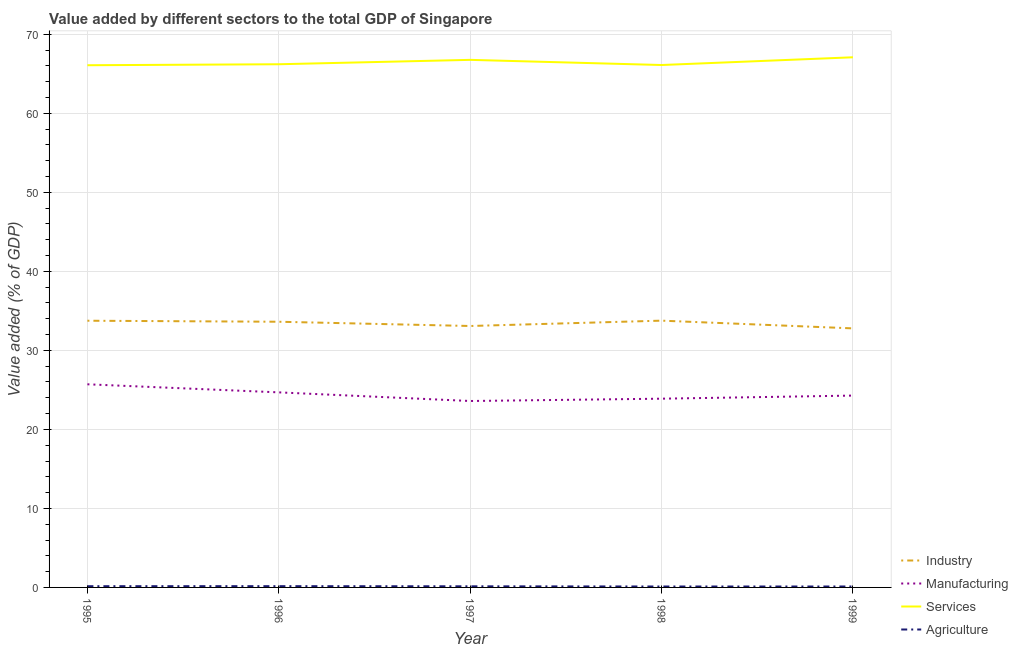Does the line corresponding to value added by services sector intersect with the line corresponding to value added by agricultural sector?
Give a very brief answer. No. Is the number of lines equal to the number of legend labels?
Make the answer very short. Yes. What is the value added by agricultural sector in 1996?
Make the answer very short. 0.16. Across all years, what is the maximum value added by industrial sector?
Offer a terse response. 33.76. Across all years, what is the minimum value added by industrial sector?
Your answer should be compact. 32.79. In which year was the value added by services sector maximum?
Your response must be concise. 1999. What is the total value added by manufacturing sector in the graph?
Your answer should be very brief. 122.16. What is the difference between the value added by agricultural sector in 1998 and that in 1999?
Make the answer very short. -0. What is the difference between the value added by industrial sector in 1999 and the value added by services sector in 1998?
Make the answer very short. -33.33. What is the average value added by industrial sector per year?
Your response must be concise. 33.4. In the year 1995, what is the difference between the value added by manufacturing sector and value added by agricultural sector?
Ensure brevity in your answer.  25.55. In how many years, is the value added by services sector greater than 12 %?
Offer a terse response. 5. What is the ratio of the value added by agricultural sector in 1995 to that in 1996?
Provide a succinct answer. 0.97. Is the difference between the value added by agricultural sector in 1997 and 1999 greater than the difference between the value added by industrial sector in 1997 and 1999?
Keep it short and to the point. No. What is the difference between the highest and the second highest value added by manufacturing sector?
Offer a very short reply. 1.02. What is the difference between the highest and the lowest value added by industrial sector?
Your answer should be compact. 0.98. In how many years, is the value added by services sector greater than the average value added by services sector taken over all years?
Your answer should be compact. 2. Is the value added by industrial sector strictly greater than the value added by agricultural sector over the years?
Your answer should be compact. Yes. Is the value added by services sector strictly less than the value added by manufacturing sector over the years?
Your response must be concise. No. How many lines are there?
Provide a succinct answer. 4. Where does the legend appear in the graph?
Make the answer very short. Bottom right. How many legend labels are there?
Your response must be concise. 4. What is the title of the graph?
Give a very brief answer. Value added by different sectors to the total GDP of Singapore. Does "Denmark" appear as one of the legend labels in the graph?
Your response must be concise. No. What is the label or title of the X-axis?
Offer a terse response. Year. What is the label or title of the Y-axis?
Provide a succinct answer. Value added (% of GDP). What is the Value added (% of GDP) of Industry in 1995?
Keep it short and to the point. 33.75. What is the Value added (% of GDP) in Manufacturing in 1995?
Offer a terse response. 25.71. What is the Value added (% of GDP) of Services in 1995?
Provide a succinct answer. 66.09. What is the Value added (% of GDP) in Agriculture in 1995?
Offer a very short reply. 0.16. What is the Value added (% of GDP) in Industry in 1996?
Make the answer very short. 33.63. What is the Value added (% of GDP) in Manufacturing in 1996?
Your answer should be compact. 24.69. What is the Value added (% of GDP) of Services in 1996?
Provide a short and direct response. 66.21. What is the Value added (% of GDP) in Agriculture in 1996?
Your response must be concise. 0.16. What is the Value added (% of GDP) in Industry in 1997?
Your answer should be very brief. 33.09. What is the Value added (% of GDP) of Manufacturing in 1997?
Give a very brief answer. 23.59. What is the Value added (% of GDP) in Services in 1997?
Your response must be concise. 66.77. What is the Value added (% of GDP) in Agriculture in 1997?
Your answer should be very brief. 0.14. What is the Value added (% of GDP) in Industry in 1998?
Give a very brief answer. 33.76. What is the Value added (% of GDP) of Manufacturing in 1998?
Make the answer very short. 23.89. What is the Value added (% of GDP) of Services in 1998?
Provide a short and direct response. 66.12. What is the Value added (% of GDP) in Agriculture in 1998?
Your answer should be compact. 0.12. What is the Value added (% of GDP) in Industry in 1999?
Provide a succinct answer. 32.79. What is the Value added (% of GDP) in Manufacturing in 1999?
Your response must be concise. 24.28. What is the Value added (% of GDP) in Services in 1999?
Offer a very short reply. 67.1. What is the Value added (% of GDP) of Agriculture in 1999?
Keep it short and to the point. 0.12. Across all years, what is the maximum Value added (% of GDP) in Industry?
Provide a succinct answer. 33.76. Across all years, what is the maximum Value added (% of GDP) of Manufacturing?
Keep it short and to the point. 25.71. Across all years, what is the maximum Value added (% of GDP) of Services?
Offer a very short reply. 67.1. Across all years, what is the maximum Value added (% of GDP) of Agriculture?
Offer a terse response. 0.16. Across all years, what is the minimum Value added (% of GDP) of Industry?
Offer a terse response. 32.79. Across all years, what is the minimum Value added (% of GDP) of Manufacturing?
Ensure brevity in your answer.  23.59. Across all years, what is the minimum Value added (% of GDP) in Services?
Provide a short and direct response. 66.09. Across all years, what is the minimum Value added (% of GDP) of Agriculture?
Your answer should be compact. 0.12. What is the total Value added (% of GDP) of Industry in the graph?
Your response must be concise. 167.02. What is the total Value added (% of GDP) of Manufacturing in the graph?
Your response must be concise. 122.16. What is the total Value added (% of GDP) in Services in the graph?
Ensure brevity in your answer.  332.29. What is the total Value added (% of GDP) in Agriculture in the graph?
Your answer should be very brief. 0.69. What is the difference between the Value added (% of GDP) of Industry in 1995 and that in 1996?
Offer a very short reply. 0.13. What is the difference between the Value added (% of GDP) of Manufacturing in 1995 and that in 1996?
Make the answer very short. 1.02. What is the difference between the Value added (% of GDP) in Services in 1995 and that in 1996?
Provide a short and direct response. -0.12. What is the difference between the Value added (% of GDP) in Agriculture in 1995 and that in 1996?
Provide a succinct answer. -0. What is the difference between the Value added (% of GDP) of Industry in 1995 and that in 1997?
Make the answer very short. 0.67. What is the difference between the Value added (% of GDP) in Manufacturing in 1995 and that in 1997?
Keep it short and to the point. 2.12. What is the difference between the Value added (% of GDP) in Services in 1995 and that in 1997?
Ensure brevity in your answer.  -0.68. What is the difference between the Value added (% of GDP) of Agriculture in 1995 and that in 1997?
Give a very brief answer. 0.01. What is the difference between the Value added (% of GDP) in Industry in 1995 and that in 1998?
Make the answer very short. -0.01. What is the difference between the Value added (% of GDP) of Manufacturing in 1995 and that in 1998?
Offer a very short reply. 1.82. What is the difference between the Value added (% of GDP) in Services in 1995 and that in 1998?
Offer a terse response. -0.03. What is the difference between the Value added (% of GDP) of Agriculture in 1995 and that in 1998?
Provide a short and direct response. 0.04. What is the difference between the Value added (% of GDP) in Manufacturing in 1995 and that in 1999?
Your response must be concise. 1.43. What is the difference between the Value added (% of GDP) of Services in 1995 and that in 1999?
Ensure brevity in your answer.  -1.01. What is the difference between the Value added (% of GDP) of Agriculture in 1995 and that in 1999?
Make the answer very short. 0.04. What is the difference between the Value added (% of GDP) in Industry in 1996 and that in 1997?
Your answer should be compact. 0.54. What is the difference between the Value added (% of GDP) in Manufacturing in 1996 and that in 1997?
Offer a very short reply. 1.09. What is the difference between the Value added (% of GDP) in Services in 1996 and that in 1997?
Make the answer very short. -0.56. What is the difference between the Value added (% of GDP) of Agriculture in 1996 and that in 1997?
Offer a very short reply. 0.02. What is the difference between the Value added (% of GDP) of Industry in 1996 and that in 1998?
Ensure brevity in your answer.  -0.14. What is the difference between the Value added (% of GDP) in Manufacturing in 1996 and that in 1998?
Your answer should be very brief. 0.8. What is the difference between the Value added (% of GDP) of Services in 1996 and that in 1998?
Ensure brevity in your answer.  0.1. What is the difference between the Value added (% of GDP) in Agriculture in 1996 and that in 1998?
Make the answer very short. 0.04. What is the difference between the Value added (% of GDP) of Industry in 1996 and that in 1999?
Make the answer very short. 0.84. What is the difference between the Value added (% of GDP) of Manufacturing in 1996 and that in 1999?
Your answer should be very brief. 0.41. What is the difference between the Value added (% of GDP) of Services in 1996 and that in 1999?
Offer a very short reply. -0.88. What is the difference between the Value added (% of GDP) in Agriculture in 1996 and that in 1999?
Make the answer very short. 0.04. What is the difference between the Value added (% of GDP) of Industry in 1997 and that in 1998?
Your answer should be compact. -0.68. What is the difference between the Value added (% of GDP) in Manufacturing in 1997 and that in 1998?
Provide a succinct answer. -0.29. What is the difference between the Value added (% of GDP) of Services in 1997 and that in 1998?
Provide a short and direct response. 0.65. What is the difference between the Value added (% of GDP) of Agriculture in 1997 and that in 1998?
Your answer should be compact. 0.02. What is the difference between the Value added (% of GDP) in Industry in 1997 and that in 1999?
Give a very brief answer. 0.3. What is the difference between the Value added (% of GDP) of Manufacturing in 1997 and that in 1999?
Ensure brevity in your answer.  -0.69. What is the difference between the Value added (% of GDP) of Services in 1997 and that in 1999?
Your response must be concise. -0.33. What is the difference between the Value added (% of GDP) in Agriculture in 1997 and that in 1999?
Provide a short and direct response. 0.02. What is the difference between the Value added (% of GDP) of Industry in 1998 and that in 1999?
Offer a terse response. 0.98. What is the difference between the Value added (% of GDP) in Manufacturing in 1998 and that in 1999?
Give a very brief answer. -0.39. What is the difference between the Value added (% of GDP) in Services in 1998 and that in 1999?
Provide a short and direct response. -0.98. What is the difference between the Value added (% of GDP) of Agriculture in 1998 and that in 1999?
Give a very brief answer. -0. What is the difference between the Value added (% of GDP) in Industry in 1995 and the Value added (% of GDP) in Manufacturing in 1996?
Ensure brevity in your answer.  9.07. What is the difference between the Value added (% of GDP) of Industry in 1995 and the Value added (% of GDP) of Services in 1996?
Give a very brief answer. -32.46. What is the difference between the Value added (% of GDP) in Industry in 1995 and the Value added (% of GDP) in Agriculture in 1996?
Offer a terse response. 33.59. What is the difference between the Value added (% of GDP) of Manufacturing in 1995 and the Value added (% of GDP) of Services in 1996?
Offer a terse response. -40.5. What is the difference between the Value added (% of GDP) of Manufacturing in 1995 and the Value added (% of GDP) of Agriculture in 1996?
Provide a short and direct response. 25.55. What is the difference between the Value added (% of GDP) in Services in 1995 and the Value added (% of GDP) in Agriculture in 1996?
Keep it short and to the point. 65.93. What is the difference between the Value added (% of GDP) in Industry in 1995 and the Value added (% of GDP) in Manufacturing in 1997?
Provide a succinct answer. 10.16. What is the difference between the Value added (% of GDP) of Industry in 1995 and the Value added (% of GDP) of Services in 1997?
Make the answer very short. -33.02. What is the difference between the Value added (% of GDP) in Industry in 1995 and the Value added (% of GDP) in Agriculture in 1997?
Provide a short and direct response. 33.61. What is the difference between the Value added (% of GDP) of Manufacturing in 1995 and the Value added (% of GDP) of Services in 1997?
Your answer should be very brief. -41.06. What is the difference between the Value added (% of GDP) of Manufacturing in 1995 and the Value added (% of GDP) of Agriculture in 1997?
Offer a very short reply. 25.57. What is the difference between the Value added (% of GDP) in Services in 1995 and the Value added (% of GDP) in Agriculture in 1997?
Your response must be concise. 65.95. What is the difference between the Value added (% of GDP) of Industry in 1995 and the Value added (% of GDP) of Manufacturing in 1998?
Ensure brevity in your answer.  9.87. What is the difference between the Value added (% of GDP) in Industry in 1995 and the Value added (% of GDP) in Services in 1998?
Keep it short and to the point. -32.36. What is the difference between the Value added (% of GDP) of Industry in 1995 and the Value added (% of GDP) of Agriculture in 1998?
Provide a succinct answer. 33.64. What is the difference between the Value added (% of GDP) of Manufacturing in 1995 and the Value added (% of GDP) of Services in 1998?
Provide a short and direct response. -40.41. What is the difference between the Value added (% of GDP) in Manufacturing in 1995 and the Value added (% of GDP) in Agriculture in 1998?
Offer a very short reply. 25.59. What is the difference between the Value added (% of GDP) in Services in 1995 and the Value added (% of GDP) in Agriculture in 1998?
Provide a succinct answer. 65.97. What is the difference between the Value added (% of GDP) in Industry in 1995 and the Value added (% of GDP) in Manufacturing in 1999?
Give a very brief answer. 9.47. What is the difference between the Value added (% of GDP) of Industry in 1995 and the Value added (% of GDP) of Services in 1999?
Your answer should be very brief. -33.34. What is the difference between the Value added (% of GDP) in Industry in 1995 and the Value added (% of GDP) in Agriculture in 1999?
Make the answer very short. 33.64. What is the difference between the Value added (% of GDP) of Manufacturing in 1995 and the Value added (% of GDP) of Services in 1999?
Make the answer very short. -41.39. What is the difference between the Value added (% of GDP) in Manufacturing in 1995 and the Value added (% of GDP) in Agriculture in 1999?
Offer a terse response. 25.59. What is the difference between the Value added (% of GDP) in Services in 1995 and the Value added (% of GDP) in Agriculture in 1999?
Make the answer very short. 65.97. What is the difference between the Value added (% of GDP) of Industry in 1996 and the Value added (% of GDP) of Manufacturing in 1997?
Offer a very short reply. 10.03. What is the difference between the Value added (% of GDP) of Industry in 1996 and the Value added (% of GDP) of Services in 1997?
Offer a terse response. -33.15. What is the difference between the Value added (% of GDP) of Industry in 1996 and the Value added (% of GDP) of Agriculture in 1997?
Provide a short and direct response. 33.48. What is the difference between the Value added (% of GDP) of Manufacturing in 1996 and the Value added (% of GDP) of Services in 1997?
Your answer should be very brief. -42.08. What is the difference between the Value added (% of GDP) of Manufacturing in 1996 and the Value added (% of GDP) of Agriculture in 1997?
Offer a terse response. 24.55. What is the difference between the Value added (% of GDP) in Services in 1996 and the Value added (% of GDP) in Agriculture in 1997?
Your answer should be very brief. 66.07. What is the difference between the Value added (% of GDP) of Industry in 1996 and the Value added (% of GDP) of Manufacturing in 1998?
Your answer should be compact. 9.74. What is the difference between the Value added (% of GDP) in Industry in 1996 and the Value added (% of GDP) in Services in 1998?
Your answer should be compact. -32.49. What is the difference between the Value added (% of GDP) of Industry in 1996 and the Value added (% of GDP) of Agriculture in 1998?
Ensure brevity in your answer.  33.51. What is the difference between the Value added (% of GDP) of Manufacturing in 1996 and the Value added (% of GDP) of Services in 1998?
Make the answer very short. -41.43. What is the difference between the Value added (% of GDP) of Manufacturing in 1996 and the Value added (% of GDP) of Agriculture in 1998?
Provide a succinct answer. 24.57. What is the difference between the Value added (% of GDP) of Services in 1996 and the Value added (% of GDP) of Agriculture in 1998?
Offer a terse response. 66.1. What is the difference between the Value added (% of GDP) in Industry in 1996 and the Value added (% of GDP) in Manufacturing in 1999?
Keep it short and to the point. 9.34. What is the difference between the Value added (% of GDP) of Industry in 1996 and the Value added (% of GDP) of Services in 1999?
Make the answer very short. -33.47. What is the difference between the Value added (% of GDP) of Industry in 1996 and the Value added (% of GDP) of Agriculture in 1999?
Provide a short and direct response. 33.51. What is the difference between the Value added (% of GDP) in Manufacturing in 1996 and the Value added (% of GDP) in Services in 1999?
Your answer should be very brief. -42.41. What is the difference between the Value added (% of GDP) of Manufacturing in 1996 and the Value added (% of GDP) of Agriculture in 1999?
Provide a succinct answer. 24.57. What is the difference between the Value added (% of GDP) in Services in 1996 and the Value added (% of GDP) in Agriculture in 1999?
Your response must be concise. 66.1. What is the difference between the Value added (% of GDP) of Industry in 1997 and the Value added (% of GDP) of Manufacturing in 1998?
Make the answer very short. 9.2. What is the difference between the Value added (% of GDP) in Industry in 1997 and the Value added (% of GDP) in Services in 1998?
Provide a succinct answer. -33.03. What is the difference between the Value added (% of GDP) in Industry in 1997 and the Value added (% of GDP) in Agriculture in 1998?
Keep it short and to the point. 32.97. What is the difference between the Value added (% of GDP) of Manufacturing in 1997 and the Value added (% of GDP) of Services in 1998?
Your response must be concise. -42.52. What is the difference between the Value added (% of GDP) of Manufacturing in 1997 and the Value added (% of GDP) of Agriculture in 1998?
Give a very brief answer. 23.48. What is the difference between the Value added (% of GDP) of Services in 1997 and the Value added (% of GDP) of Agriculture in 1998?
Provide a short and direct response. 66.65. What is the difference between the Value added (% of GDP) of Industry in 1997 and the Value added (% of GDP) of Manufacturing in 1999?
Provide a short and direct response. 8.81. What is the difference between the Value added (% of GDP) in Industry in 1997 and the Value added (% of GDP) in Services in 1999?
Offer a very short reply. -34.01. What is the difference between the Value added (% of GDP) in Industry in 1997 and the Value added (% of GDP) in Agriculture in 1999?
Provide a short and direct response. 32.97. What is the difference between the Value added (% of GDP) in Manufacturing in 1997 and the Value added (% of GDP) in Services in 1999?
Your answer should be very brief. -43.5. What is the difference between the Value added (% of GDP) in Manufacturing in 1997 and the Value added (% of GDP) in Agriculture in 1999?
Ensure brevity in your answer.  23.48. What is the difference between the Value added (% of GDP) of Services in 1997 and the Value added (% of GDP) of Agriculture in 1999?
Make the answer very short. 66.65. What is the difference between the Value added (% of GDP) in Industry in 1998 and the Value added (% of GDP) in Manufacturing in 1999?
Provide a short and direct response. 9.48. What is the difference between the Value added (% of GDP) in Industry in 1998 and the Value added (% of GDP) in Services in 1999?
Your answer should be compact. -33.33. What is the difference between the Value added (% of GDP) of Industry in 1998 and the Value added (% of GDP) of Agriculture in 1999?
Provide a succinct answer. 33.65. What is the difference between the Value added (% of GDP) of Manufacturing in 1998 and the Value added (% of GDP) of Services in 1999?
Give a very brief answer. -43.21. What is the difference between the Value added (% of GDP) in Manufacturing in 1998 and the Value added (% of GDP) in Agriculture in 1999?
Give a very brief answer. 23.77. What is the difference between the Value added (% of GDP) of Services in 1998 and the Value added (% of GDP) of Agriculture in 1999?
Your answer should be very brief. 66. What is the average Value added (% of GDP) in Industry per year?
Provide a succinct answer. 33.4. What is the average Value added (% of GDP) in Manufacturing per year?
Your answer should be very brief. 24.43. What is the average Value added (% of GDP) in Services per year?
Offer a terse response. 66.46. What is the average Value added (% of GDP) in Agriculture per year?
Your answer should be compact. 0.14. In the year 1995, what is the difference between the Value added (% of GDP) of Industry and Value added (% of GDP) of Manufacturing?
Give a very brief answer. 8.04. In the year 1995, what is the difference between the Value added (% of GDP) of Industry and Value added (% of GDP) of Services?
Make the answer very short. -32.34. In the year 1995, what is the difference between the Value added (% of GDP) in Industry and Value added (% of GDP) in Agriculture?
Offer a very short reply. 33.6. In the year 1995, what is the difference between the Value added (% of GDP) of Manufacturing and Value added (% of GDP) of Services?
Keep it short and to the point. -40.38. In the year 1995, what is the difference between the Value added (% of GDP) of Manufacturing and Value added (% of GDP) of Agriculture?
Offer a very short reply. 25.55. In the year 1995, what is the difference between the Value added (% of GDP) of Services and Value added (% of GDP) of Agriculture?
Ensure brevity in your answer.  65.94. In the year 1996, what is the difference between the Value added (% of GDP) in Industry and Value added (% of GDP) in Manufacturing?
Your response must be concise. 8.94. In the year 1996, what is the difference between the Value added (% of GDP) of Industry and Value added (% of GDP) of Services?
Keep it short and to the point. -32.59. In the year 1996, what is the difference between the Value added (% of GDP) of Industry and Value added (% of GDP) of Agriculture?
Make the answer very short. 33.47. In the year 1996, what is the difference between the Value added (% of GDP) of Manufacturing and Value added (% of GDP) of Services?
Offer a very short reply. -41.53. In the year 1996, what is the difference between the Value added (% of GDP) in Manufacturing and Value added (% of GDP) in Agriculture?
Make the answer very short. 24.53. In the year 1996, what is the difference between the Value added (% of GDP) of Services and Value added (% of GDP) of Agriculture?
Offer a very short reply. 66.05. In the year 1997, what is the difference between the Value added (% of GDP) of Industry and Value added (% of GDP) of Manufacturing?
Provide a short and direct response. 9.49. In the year 1997, what is the difference between the Value added (% of GDP) in Industry and Value added (% of GDP) in Services?
Your answer should be compact. -33.68. In the year 1997, what is the difference between the Value added (% of GDP) of Industry and Value added (% of GDP) of Agriculture?
Give a very brief answer. 32.95. In the year 1997, what is the difference between the Value added (% of GDP) of Manufacturing and Value added (% of GDP) of Services?
Offer a very short reply. -43.18. In the year 1997, what is the difference between the Value added (% of GDP) of Manufacturing and Value added (% of GDP) of Agriculture?
Give a very brief answer. 23.45. In the year 1997, what is the difference between the Value added (% of GDP) in Services and Value added (% of GDP) in Agriculture?
Provide a short and direct response. 66.63. In the year 1998, what is the difference between the Value added (% of GDP) in Industry and Value added (% of GDP) in Manufacturing?
Make the answer very short. 9.88. In the year 1998, what is the difference between the Value added (% of GDP) of Industry and Value added (% of GDP) of Services?
Your answer should be compact. -32.35. In the year 1998, what is the difference between the Value added (% of GDP) in Industry and Value added (% of GDP) in Agriculture?
Make the answer very short. 33.65. In the year 1998, what is the difference between the Value added (% of GDP) in Manufacturing and Value added (% of GDP) in Services?
Your answer should be very brief. -42.23. In the year 1998, what is the difference between the Value added (% of GDP) in Manufacturing and Value added (% of GDP) in Agriculture?
Provide a succinct answer. 23.77. In the year 1998, what is the difference between the Value added (% of GDP) in Services and Value added (% of GDP) in Agriculture?
Your answer should be compact. 66. In the year 1999, what is the difference between the Value added (% of GDP) of Industry and Value added (% of GDP) of Manufacturing?
Provide a short and direct response. 8.5. In the year 1999, what is the difference between the Value added (% of GDP) in Industry and Value added (% of GDP) in Services?
Offer a terse response. -34.31. In the year 1999, what is the difference between the Value added (% of GDP) in Industry and Value added (% of GDP) in Agriculture?
Make the answer very short. 32.67. In the year 1999, what is the difference between the Value added (% of GDP) of Manufacturing and Value added (% of GDP) of Services?
Offer a very short reply. -42.81. In the year 1999, what is the difference between the Value added (% of GDP) in Manufacturing and Value added (% of GDP) in Agriculture?
Provide a succinct answer. 24.16. In the year 1999, what is the difference between the Value added (% of GDP) of Services and Value added (% of GDP) of Agriculture?
Ensure brevity in your answer.  66.98. What is the ratio of the Value added (% of GDP) in Industry in 1995 to that in 1996?
Your response must be concise. 1. What is the ratio of the Value added (% of GDP) of Manufacturing in 1995 to that in 1996?
Provide a succinct answer. 1.04. What is the ratio of the Value added (% of GDP) in Services in 1995 to that in 1996?
Offer a terse response. 1. What is the ratio of the Value added (% of GDP) of Agriculture in 1995 to that in 1996?
Ensure brevity in your answer.  0.97. What is the ratio of the Value added (% of GDP) in Industry in 1995 to that in 1997?
Your answer should be very brief. 1.02. What is the ratio of the Value added (% of GDP) of Manufacturing in 1995 to that in 1997?
Make the answer very short. 1.09. What is the ratio of the Value added (% of GDP) in Services in 1995 to that in 1997?
Give a very brief answer. 0.99. What is the ratio of the Value added (% of GDP) in Agriculture in 1995 to that in 1997?
Give a very brief answer. 1.1. What is the ratio of the Value added (% of GDP) of Manufacturing in 1995 to that in 1998?
Your answer should be very brief. 1.08. What is the ratio of the Value added (% of GDP) in Services in 1995 to that in 1998?
Provide a succinct answer. 1. What is the ratio of the Value added (% of GDP) of Agriculture in 1995 to that in 1998?
Ensure brevity in your answer.  1.32. What is the ratio of the Value added (% of GDP) of Industry in 1995 to that in 1999?
Provide a succinct answer. 1.03. What is the ratio of the Value added (% of GDP) in Manufacturing in 1995 to that in 1999?
Offer a terse response. 1.06. What is the ratio of the Value added (% of GDP) in Services in 1995 to that in 1999?
Provide a succinct answer. 0.98. What is the ratio of the Value added (% of GDP) in Agriculture in 1995 to that in 1999?
Keep it short and to the point. 1.31. What is the ratio of the Value added (% of GDP) of Industry in 1996 to that in 1997?
Make the answer very short. 1.02. What is the ratio of the Value added (% of GDP) in Manufacturing in 1996 to that in 1997?
Make the answer very short. 1.05. What is the ratio of the Value added (% of GDP) in Services in 1996 to that in 1997?
Keep it short and to the point. 0.99. What is the ratio of the Value added (% of GDP) in Agriculture in 1996 to that in 1997?
Your answer should be compact. 1.13. What is the ratio of the Value added (% of GDP) of Manufacturing in 1996 to that in 1998?
Your answer should be compact. 1.03. What is the ratio of the Value added (% of GDP) of Services in 1996 to that in 1998?
Make the answer very short. 1. What is the ratio of the Value added (% of GDP) of Agriculture in 1996 to that in 1998?
Offer a very short reply. 1.36. What is the ratio of the Value added (% of GDP) of Industry in 1996 to that in 1999?
Provide a succinct answer. 1.03. What is the ratio of the Value added (% of GDP) of Manufacturing in 1996 to that in 1999?
Your response must be concise. 1.02. What is the ratio of the Value added (% of GDP) of Services in 1996 to that in 1999?
Your response must be concise. 0.99. What is the ratio of the Value added (% of GDP) of Agriculture in 1996 to that in 1999?
Your answer should be compact. 1.35. What is the ratio of the Value added (% of GDP) in Industry in 1997 to that in 1998?
Make the answer very short. 0.98. What is the ratio of the Value added (% of GDP) of Services in 1997 to that in 1998?
Offer a terse response. 1.01. What is the ratio of the Value added (% of GDP) of Agriculture in 1997 to that in 1998?
Provide a succinct answer. 1.21. What is the ratio of the Value added (% of GDP) of Industry in 1997 to that in 1999?
Keep it short and to the point. 1.01. What is the ratio of the Value added (% of GDP) in Manufacturing in 1997 to that in 1999?
Keep it short and to the point. 0.97. What is the ratio of the Value added (% of GDP) of Services in 1997 to that in 1999?
Your answer should be compact. 1. What is the ratio of the Value added (% of GDP) in Agriculture in 1997 to that in 1999?
Offer a terse response. 1.2. What is the ratio of the Value added (% of GDP) in Industry in 1998 to that in 1999?
Make the answer very short. 1.03. What is the ratio of the Value added (% of GDP) of Manufacturing in 1998 to that in 1999?
Provide a short and direct response. 0.98. What is the ratio of the Value added (% of GDP) of Services in 1998 to that in 1999?
Make the answer very short. 0.99. What is the difference between the highest and the second highest Value added (% of GDP) in Industry?
Provide a short and direct response. 0.01. What is the difference between the highest and the second highest Value added (% of GDP) of Manufacturing?
Ensure brevity in your answer.  1.02. What is the difference between the highest and the second highest Value added (% of GDP) in Services?
Ensure brevity in your answer.  0.33. What is the difference between the highest and the second highest Value added (% of GDP) in Agriculture?
Your answer should be compact. 0. What is the difference between the highest and the lowest Value added (% of GDP) of Industry?
Provide a succinct answer. 0.98. What is the difference between the highest and the lowest Value added (% of GDP) in Manufacturing?
Provide a short and direct response. 2.12. What is the difference between the highest and the lowest Value added (% of GDP) of Services?
Offer a terse response. 1.01. What is the difference between the highest and the lowest Value added (% of GDP) of Agriculture?
Give a very brief answer. 0.04. 